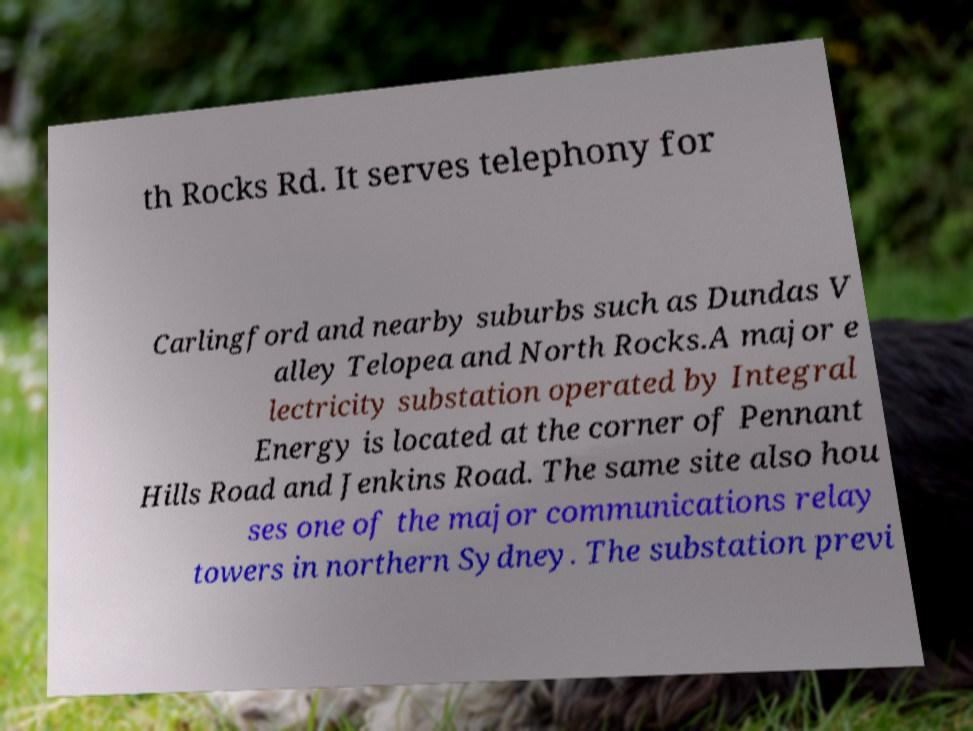Please read and relay the text visible in this image. What does it say? th Rocks Rd. It serves telephony for Carlingford and nearby suburbs such as Dundas V alley Telopea and North Rocks.A major e lectricity substation operated by Integral Energy is located at the corner of Pennant Hills Road and Jenkins Road. The same site also hou ses one of the major communications relay towers in northern Sydney. The substation previ 